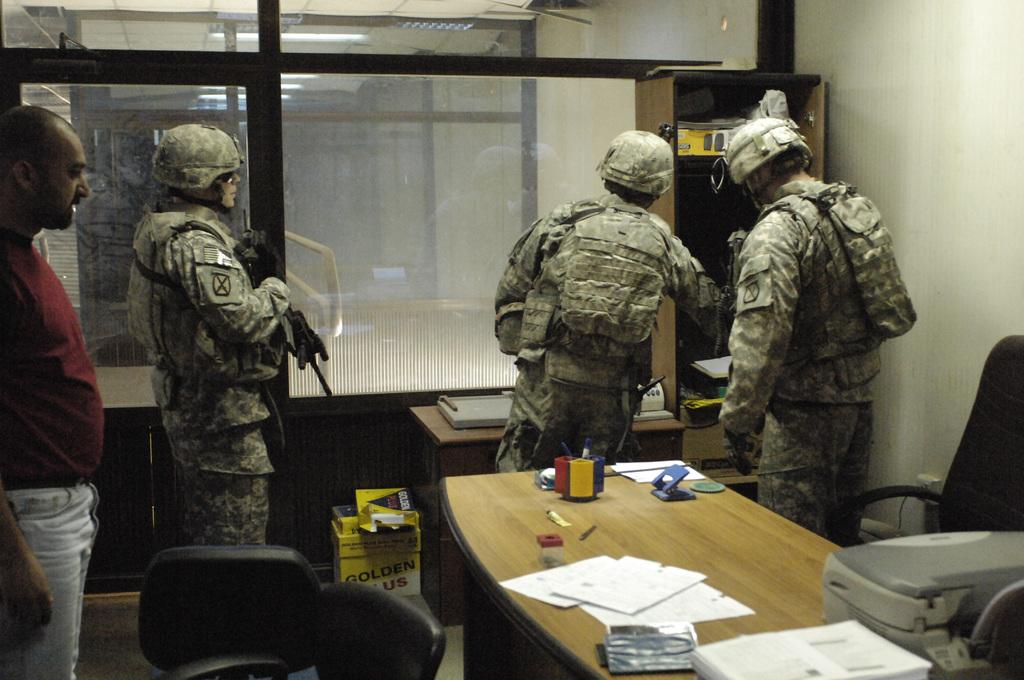How many people are in the image? There are four people in the image. What are the attire choices of three of the people? Three of the people are wearing army uniforms. What is the clothing choice of the fourth person? One person is wearing a red t-shirt. What is present on the table in the image? Papers are present on the table. What type of egg is on the floor in the image? There is no egg present in the image, and therefore no such item can be observed on the floor. 